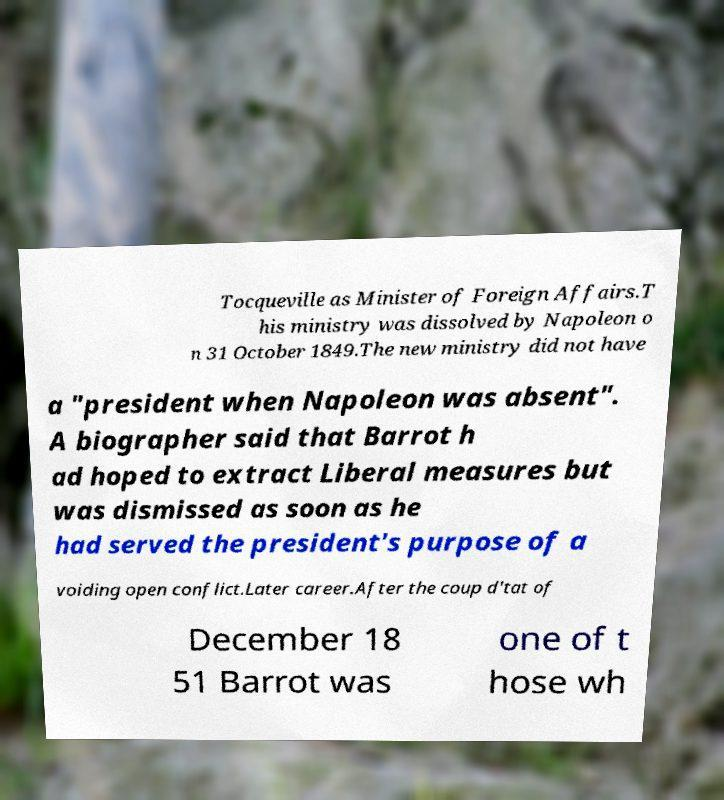For documentation purposes, I need the text within this image transcribed. Could you provide that? Tocqueville as Minister of Foreign Affairs.T his ministry was dissolved by Napoleon o n 31 October 1849.The new ministry did not have a "president when Napoleon was absent". A biographer said that Barrot h ad hoped to extract Liberal measures but was dismissed as soon as he had served the president's purpose of a voiding open conflict.Later career.After the coup d'tat of December 18 51 Barrot was one of t hose wh 